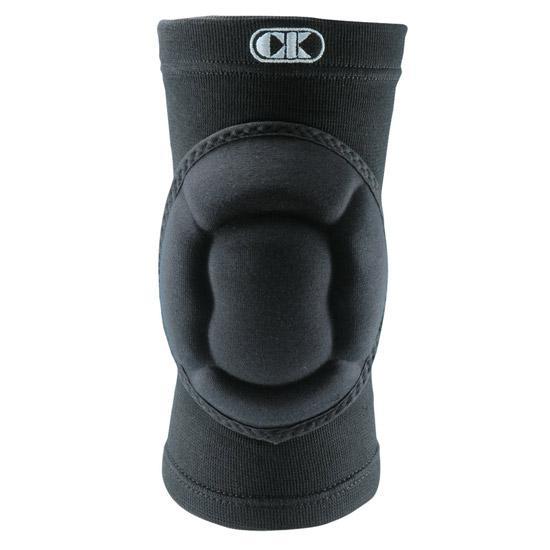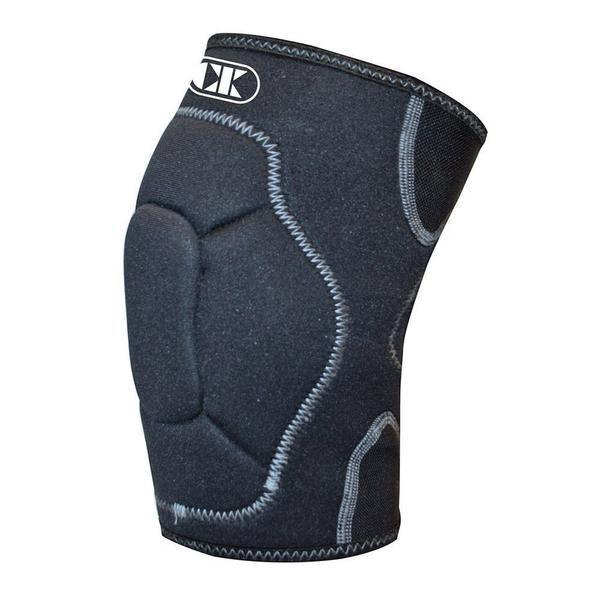The first image is the image on the left, the second image is the image on the right. Analyze the images presented: Is the assertion "The item in the image on the left is facing forward." valid? Answer yes or no. Yes. 